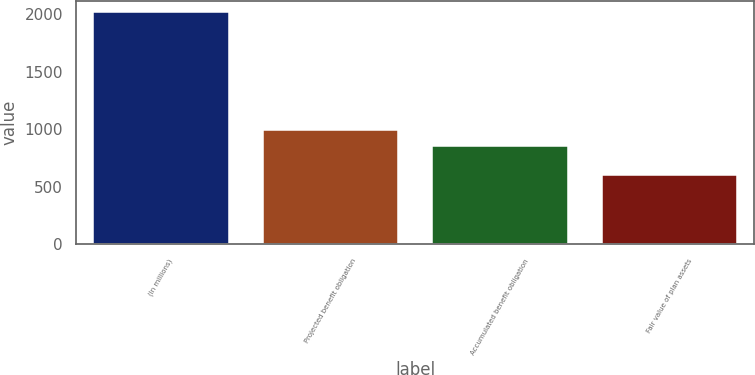<chart> <loc_0><loc_0><loc_500><loc_500><bar_chart><fcel>(In millions)<fcel>Projected benefit obligation<fcel>Accumulated benefit obligation<fcel>Fair value of plan assets<nl><fcel>2016<fcel>995.9<fcel>855<fcel>607<nl></chart> 